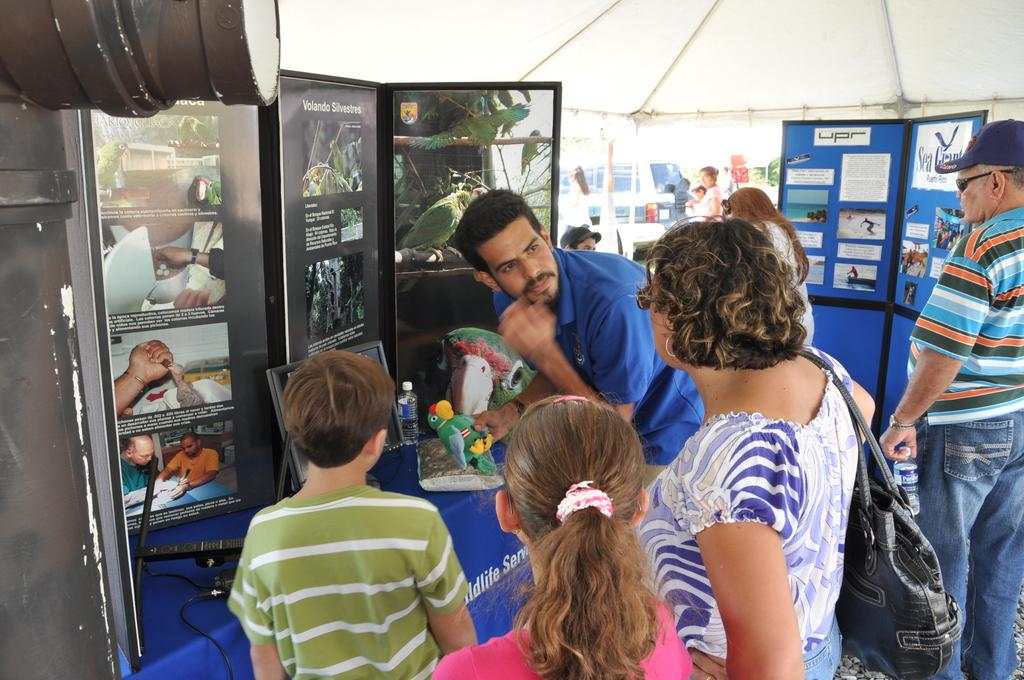How many people are in the image? There is a group of people in the image. Where are the people located in the image? The people are standing at the bottom of the image. What can be seen in the background of the image? There are posts in the background of the image. What type of worm can be seen crawling on the people in the image? There is no worm present in the image; it only features a group of people standing at the bottom and posts in the background. 